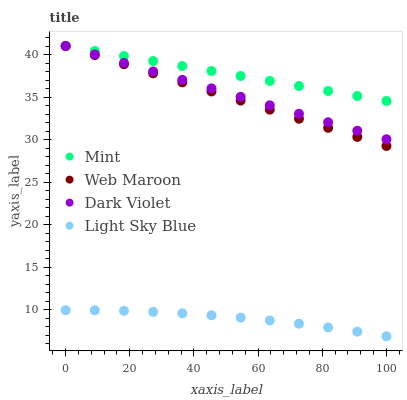Does Light Sky Blue have the minimum area under the curve?
Answer yes or no. Yes. Does Mint have the maximum area under the curve?
Answer yes or no. Yes. Does Mint have the minimum area under the curve?
Answer yes or no. No. Does Light Sky Blue have the maximum area under the curve?
Answer yes or no. No. Is Mint the smoothest?
Answer yes or no. Yes. Is Light Sky Blue the roughest?
Answer yes or no. Yes. Is Light Sky Blue the smoothest?
Answer yes or no. No. Is Mint the roughest?
Answer yes or no. No. Does Light Sky Blue have the lowest value?
Answer yes or no. Yes. Does Mint have the lowest value?
Answer yes or no. No. Does Dark Violet have the highest value?
Answer yes or no. Yes. Does Light Sky Blue have the highest value?
Answer yes or no. No. Is Light Sky Blue less than Mint?
Answer yes or no. Yes. Is Web Maroon greater than Light Sky Blue?
Answer yes or no. Yes. Does Mint intersect Dark Violet?
Answer yes or no. Yes. Is Mint less than Dark Violet?
Answer yes or no. No. Is Mint greater than Dark Violet?
Answer yes or no. No. Does Light Sky Blue intersect Mint?
Answer yes or no. No. 